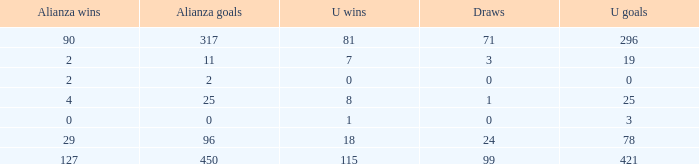What is the lowest U Wins, when Alianza Wins is greater than 0, when Alianza Goals is greater than 25, and when Draws is "99"? 115.0. 